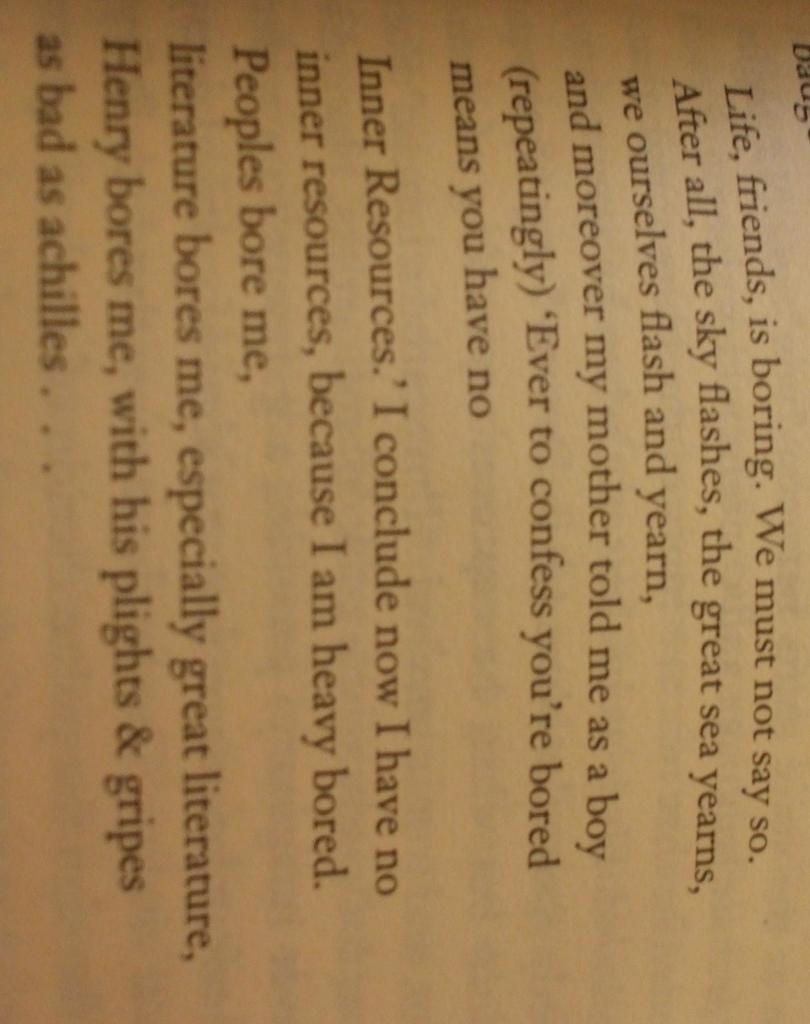Does he have inner resources?
Your answer should be very brief. No. 